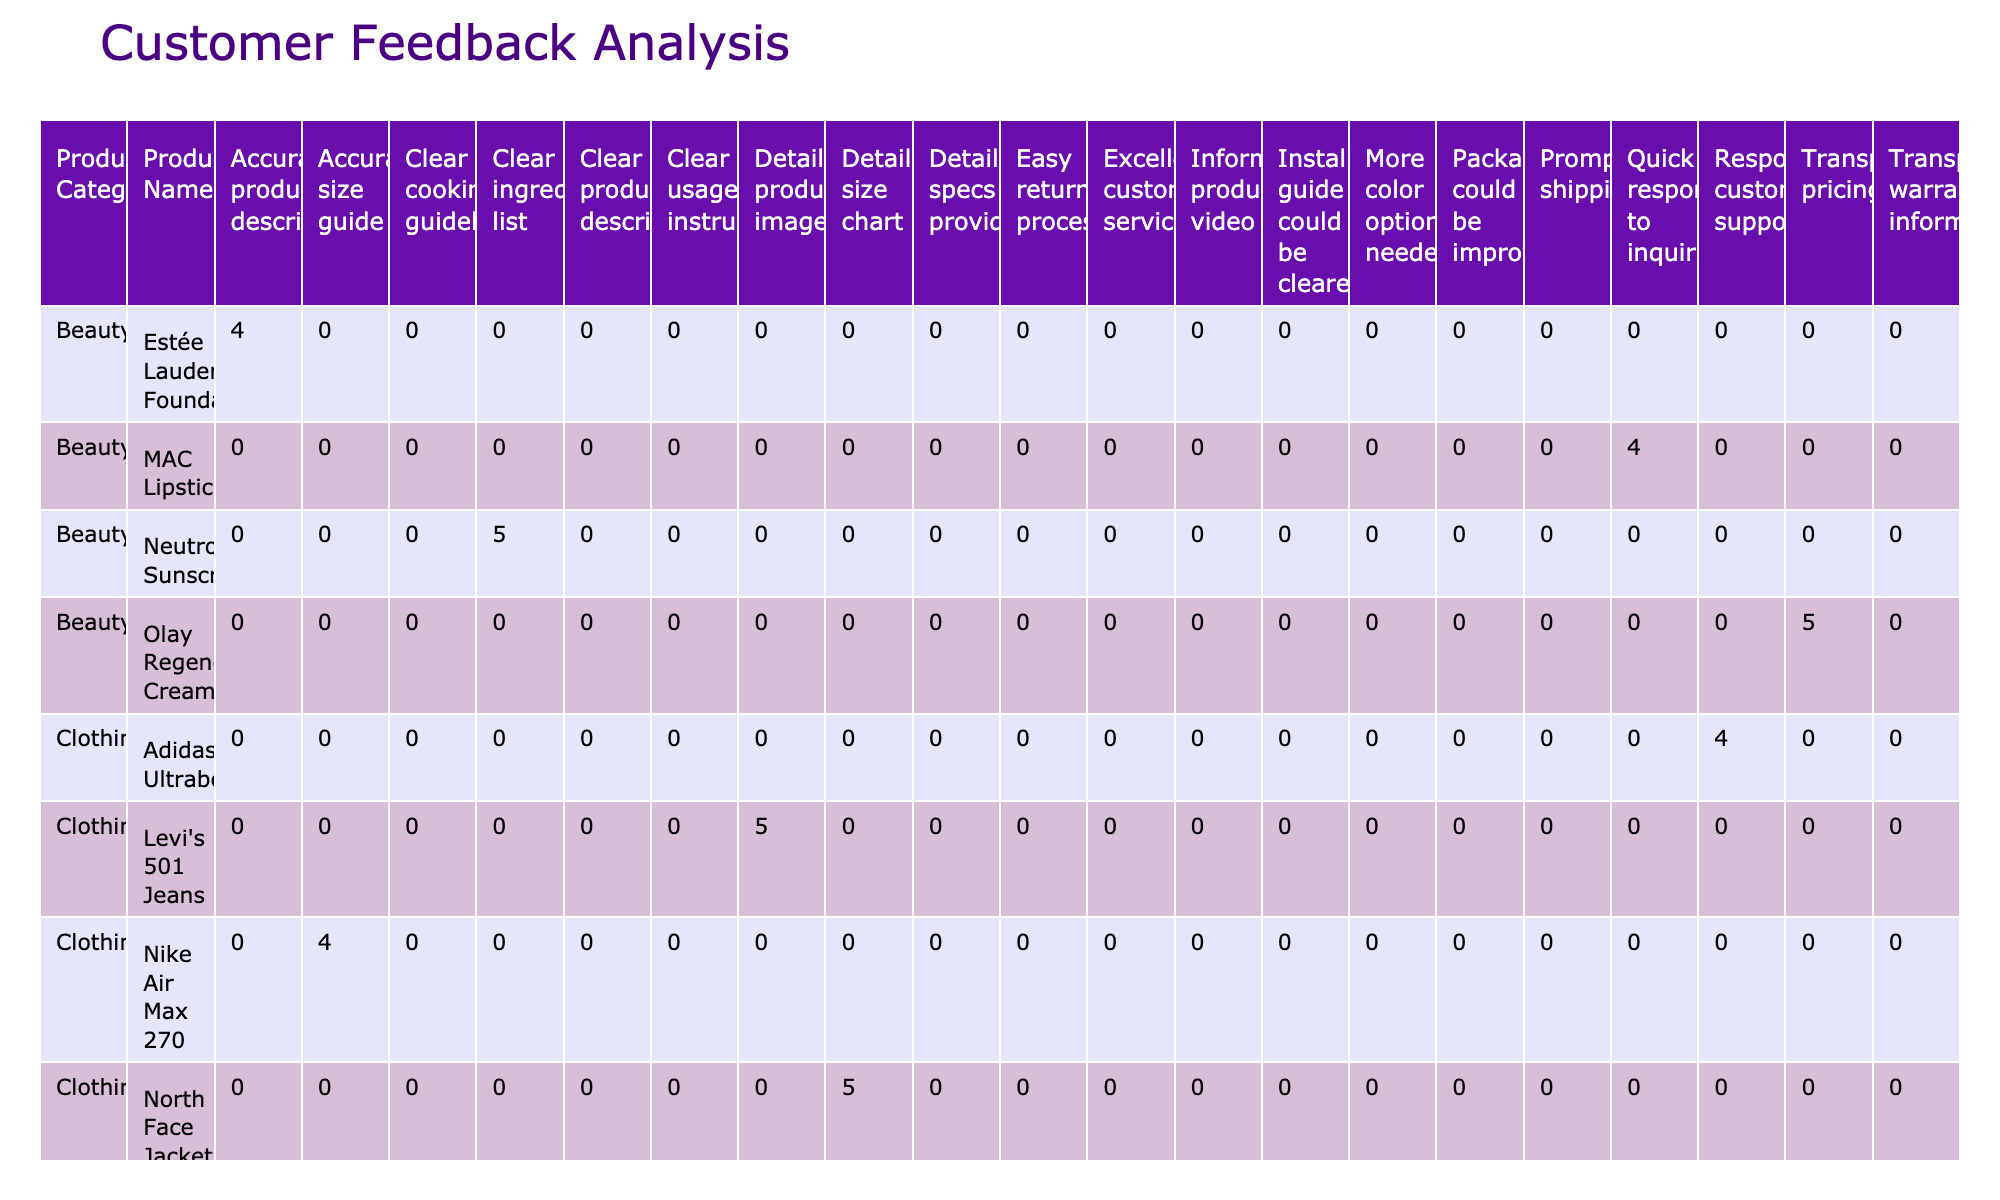What is the highest satisfaction level reported in the Electronics category? In the Electronics category, the satisfaction levels are 5 for the iPhone 13 Pro, Sony WH-1000XM4 Headphones, Dell XPS 13 Laptop, and others. The highest satisfaction level is thus 5.
Answer: 5 How many products in the Home Appliances category received a satisfaction level of 3? The Home Appliances category includes the KitchenAid Stand Mixer (3), Roomba i7+ (3), and Whirlpool Dishwasher (3). Therefore, there are three products with a satisfaction level of 3.
Answer: 3 What is the average satisfaction level for the Clothing category? The satisfaction levels in Clothing are 4 (Nike Air Max 270), 5 (Levi's 501 Jeans), 4 (Adidas Ultraboost), and 5 (North Face Jacket). Summing these gives 4 + 5 + 4 + 5 = 18, and there are 4 products; hence, the average is 18/4 = 4.5.
Answer: 4.5 Is the feedback type "Clear usage instructions" present in the Electronics category? The Electronics category includes feedback types such as "Clear product description," "Prompt shipping," and "Easy return process," but does not include "Clear usage instructions." Therefore, the statement is false.
Answer: No What is the total number of products that have a satisfaction level of 5 across all categories? In the data, the products with a satisfaction level of 5 are: iPhone 13 Pro, Dyson V11 Vacuum, Levi's 501 Jeans, Olay Regenerist Cream, Sony WH-1000XM4 Headphones, Instant Pot Duo, Dell XPS 13 Laptop, Ninja Air Fryer. There are 8 such products in total.
Answer: 8 Which product in the Beauty category has the least satisfaction level? In the Beauty category, the satisfaction levels are 4 (MAC Lipstick), 5 (Olay Regenerist Cream), 4 (Estée Lauder Foundation), and 5 (Neutrogena Sunscreen). The product with the least satisfaction level here is MAC Lipstick and Estée Lauder Foundation, both of which have a satisfaction level of 4.
Answer: 4 How many distinct feedback types were used for the Home Appliances category? Looking at the Home Appliances category, the feedback types are: "Excellent customer service," "Packaging could be improved," "Clear usage instructions," "More color options needed," and "Installation guide could be clearer," making a total of 5 distinct feedback types.
Answer: 5 Is there a product in the Electronics category with a feedback type of "More color options needed"? Reviewing the Electronics category, the feedback types do not include "More color options needed," as that type is only present in the Home Appliances category for the Roomba i7+. Therefore, the answer is no.
Answer: No 